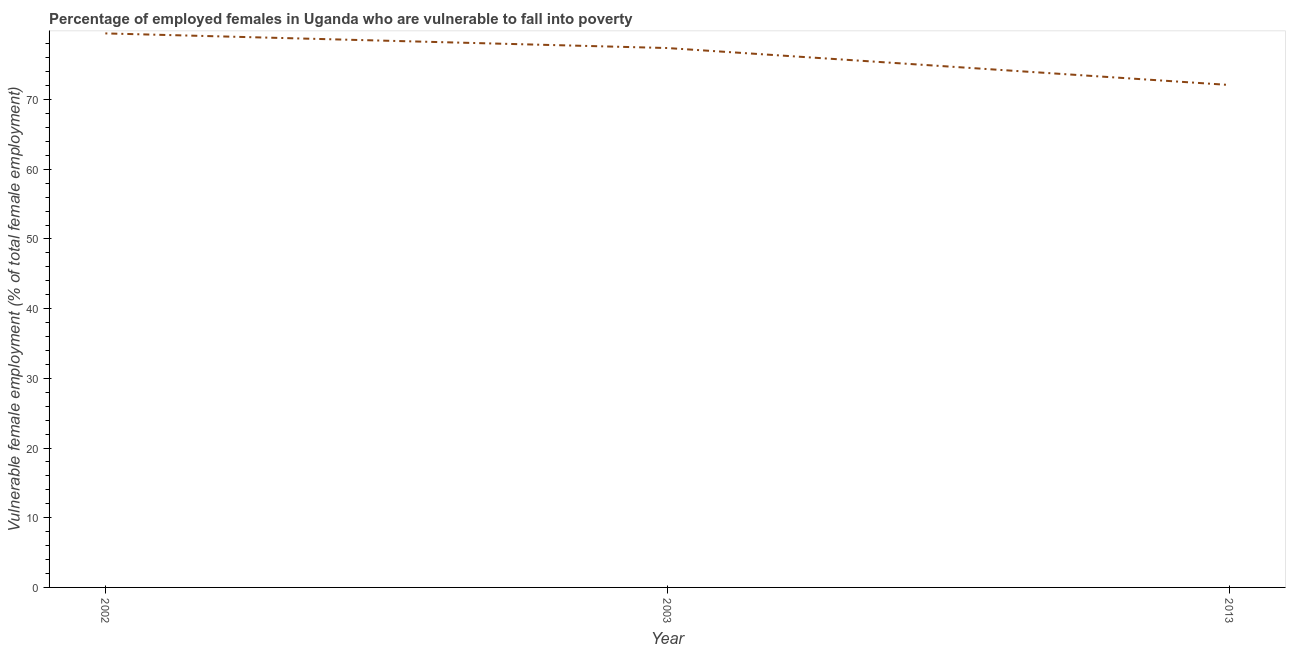What is the percentage of employed females who are vulnerable to fall into poverty in 2013?
Offer a terse response. 72.1. Across all years, what is the maximum percentage of employed females who are vulnerable to fall into poverty?
Offer a very short reply. 79.5. Across all years, what is the minimum percentage of employed females who are vulnerable to fall into poverty?
Your response must be concise. 72.1. In which year was the percentage of employed females who are vulnerable to fall into poverty maximum?
Offer a terse response. 2002. What is the sum of the percentage of employed females who are vulnerable to fall into poverty?
Provide a short and direct response. 229. What is the difference between the percentage of employed females who are vulnerable to fall into poverty in 2002 and 2003?
Offer a terse response. 2.1. What is the average percentage of employed females who are vulnerable to fall into poverty per year?
Ensure brevity in your answer.  76.33. What is the median percentage of employed females who are vulnerable to fall into poverty?
Give a very brief answer. 77.4. In how many years, is the percentage of employed females who are vulnerable to fall into poverty greater than 8 %?
Make the answer very short. 3. What is the ratio of the percentage of employed females who are vulnerable to fall into poverty in 2002 to that in 2013?
Your response must be concise. 1.1. Is the percentage of employed females who are vulnerable to fall into poverty in 2002 less than that in 2013?
Offer a very short reply. No. What is the difference between the highest and the second highest percentage of employed females who are vulnerable to fall into poverty?
Provide a short and direct response. 2.1. Is the sum of the percentage of employed females who are vulnerable to fall into poverty in 2003 and 2013 greater than the maximum percentage of employed females who are vulnerable to fall into poverty across all years?
Offer a very short reply. Yes. What is the difference between the highest and the lowest percentage of employed females who are vulnerable to fall into poverty?
Ensure brevity in your answer.  7.4. In how many years, is the percentage of employed females who are vulnerable to fall into poverty greater than the average percentage of employed females who are vulnerable to fall into poverty taken over all years?
Offer a terse response. 2. Are the values on the major ticks of Y-axis written in scientific E-notation?
Offer a terse response. No. Does the graph contain any zero values?
Your answer should be compact. No. What is the title of the graph?
Your response must be concise. Percentage of employed females in Uganda who are vulnerable to fall into poverty. What is the label or title of the Y-axis?
Provide a succinct answer. Vulnerable female employment (% of total female employment). What is the Vulnerable female employment (% of total female employment) in 2002?
Ensure brevity in your answer.  79.5. What is the Vulnerable female employment (% of total female employment) of 2003?
Your answer should be compact. 77.4. What is the Vulnerable female employment (% of total female employment) of 2013?
Give a very brief answer. 72.1. What is the difference between the Vulnerable female employment (% of total female employment) in 2002 and 2013?
Make the answer very short. 7.4. What is the difference between the Vulnerable female employment (% of total female employment) in 2003 and 2013?
Keep it short and to the point. 5.3. What is the ratio of the Vulnerable female employment (% of total female employment) in 2002 to that in 2003?
Provide a succinct answer. 1.03. What is the ratio of the Vulnerable female employment (% of total female employment) in 2002 to that in 2013?
Your answer should be very brief. 1.1. What is the ratio of the Vulnerable female employment (% of total female employment) in 2003 to that in 2013?
Ensure brevity in your answer.  1.07. 